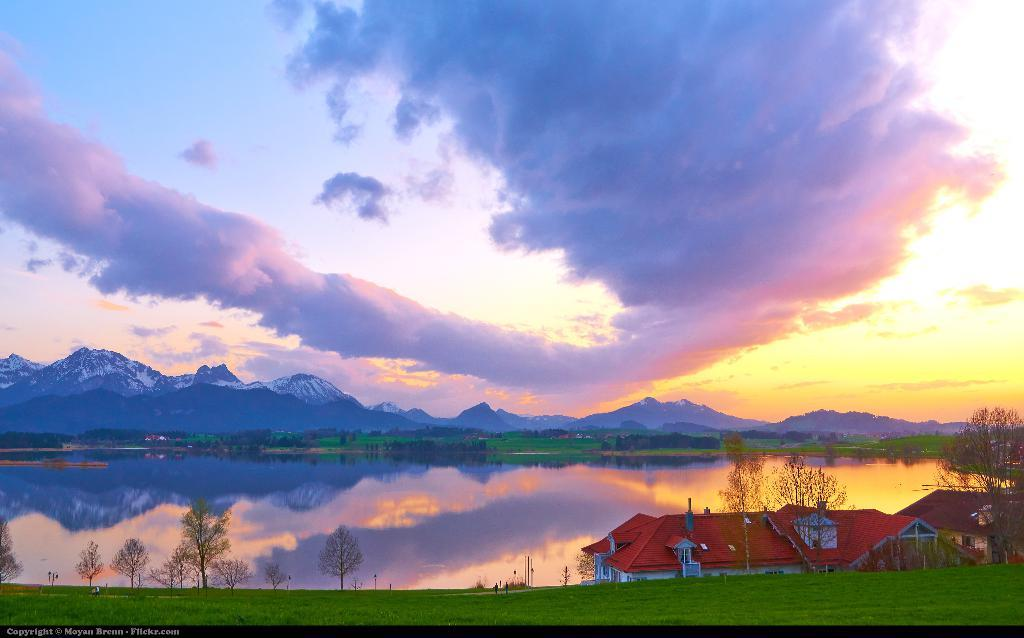What is the primary element visible in the image? There is water in the image. What type of vegetation can be seen on the ground? There is grass on the ground. What other natural elements are present in the image? There are trees in the image. Are there any man-made structures visible? Yes, there are buildings in the image. What can be seen in the distance in the image? There are hills visible in the background. What is visible in the sky in the image? The sky is visible in the image, and clouds are present. What advice does the grandfather give about digestion in the image? There is no grandfather present in the image, nor is there any discussion about digestion. 